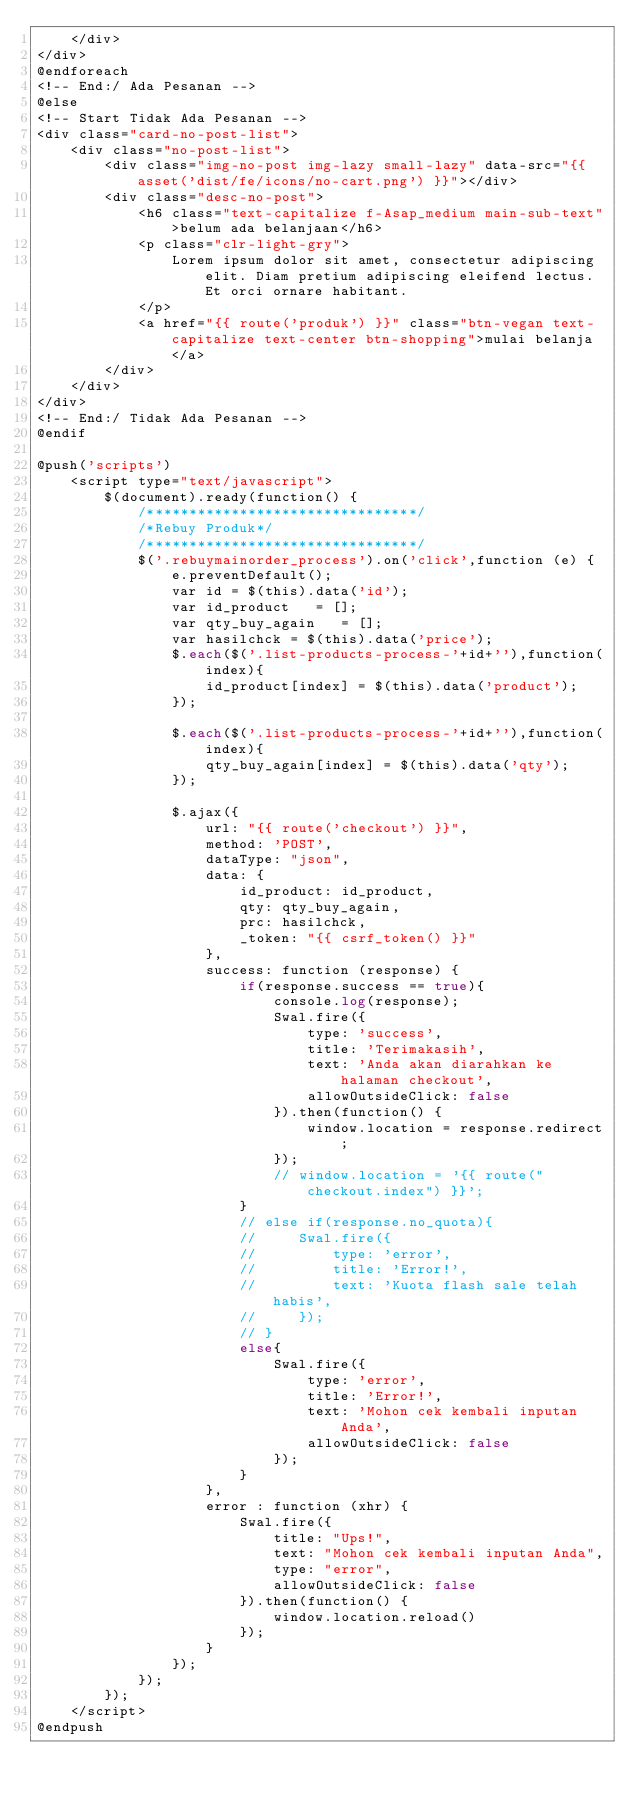Convert code to text. <code><loc_0><loc_0><loc_500><loc_500><_PHP_>    </div>
</div>
@endforeach
<!-- End:/ Ada Pesanan -->
@else
<!-- Start Tidak Ada Pesanan -->
<div class="card-no-post-list">
    <div class="no-post-list">
        <div class="img-no-post img-lazy small-lazy" data-src="{{ asset('dist/fe/icons/no-cart.png') }}"></div>
        <div class="desc-no-post">
            <h6 class="text-capitalize f-Asap_medium main-sub-text">belum ada belanjaan</h6>
            <p class="clr-light-gry">
                Lorem ipsum dolor sit amet, consectetur adipiscing elit. Diam pretium adipiscing eleifend lectus. Et orci ornare habitant.
            </p>
            <a href="{{ route('produk') }}" class="btn-vegan text-capitalize text-center btn-shopping">mulai belanja</a>
        </div>
    </div>
</div>
<!-- End:/ Tidak Ada Pesanan -->
@endif

@push('scripts')
    <script type="text/javascript">
        $(document).ready(function() {
            /********************************/
            /*Rebuy Produk*/
            /********************************/
            $('.rebuymainorder_process').on('click',function (e) {
                e.preventDefault();
                var id = $(this).data('id');
                var id_product   = [];
                var qty_buy_again   = [];
                var hasilchck = $(this).data('price');
                $.each($('.list-products-process-'+id+''),function(index){
                    id_product[index] = $(this).data('product');
                });

                $.each($('.list-products-process-'+id+''),function(index){
                    qty_buy_again[index] = $(this).data('qty');
                });

                $.ajax({
                    url: "{{ route('checkout') }}",
                    method: 'POST',
                    dataType: "json",
                    data: {
                        id_product: id_product,
                        qty: qty_buy_again,
                        prc: hasilchck,
                        _token: "{{ csrf_token() }}"
                    },
                    success: function (response) {
                        if(response.success == true){
                            console.log(response);
                            Swal.fire({
                                type: 'success',
                                title: 'Terimakasih',
                                text: 'Anda akan diarahkan ke halaman checkout',
                                allowOutsideClick: false
                            }).then(function() {
                                window.location = response.redirect;
                            });
                            // window.location = '{{ route("checkout.index") }}';
                        }
                        // else if(response.no_quota){
                        //     Swal.fire({
                        //         type: 'error',
                        //         title: 'Error!',
                        //         text: 'Kuota flash sale telah habis',
                        //     });
                        // }
                        else{
                            Swal.fire({
                                type: 'error',
                                title: 'Error!',
                                text: 'Mohon cek kembali inputan Anda',
                                allowOutsideClick: false
                            });
                        }
                    },
                    error : function (xhr) {
                        Swal.fire({
                            title: "Ups!",
                            text: "Mohon cek kembali inputan Anda",
                            type: "error",
                            allowOutsideClick: false
                        }).then(function() {
                            window.location.reload()
                        });
                    }
                });
            });
        });
    </script>
@endpush</code> 